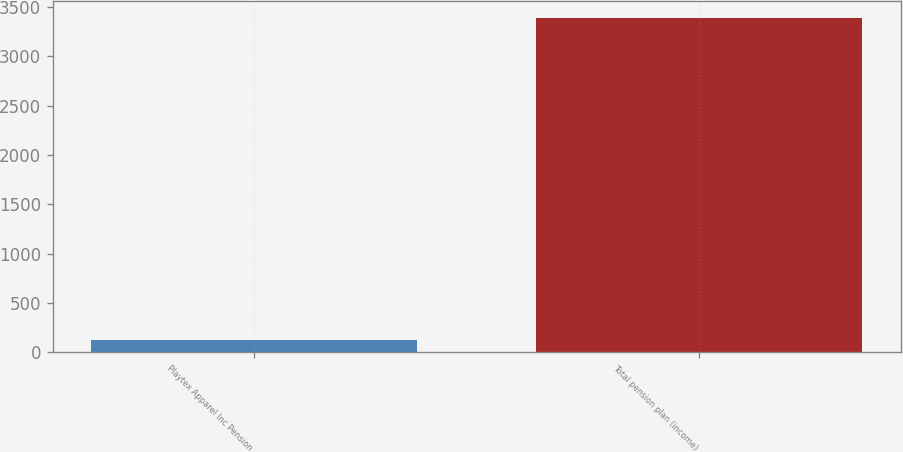Convert chart to OTSL. <chart><loc_0><loc_0><loc_500><loc_500><bar_chart><fcel>Playtex Apparel Inc Pension<fcel>Total pension plan (income)<nl><fcel>127<fcel>3390<nl></chart> 